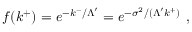Convert formula to latex. <formula><loc_0><loc_0><loc_500><loc_500>f ( k ^ { + } ) = e ^ { - k ^ { - } / \Lambda ^ { \prime } } = e ^ { - \sigma ^ { 2 } / ( \Lambda ^ { \prime } k ^ { + } ) } ,</formula> 